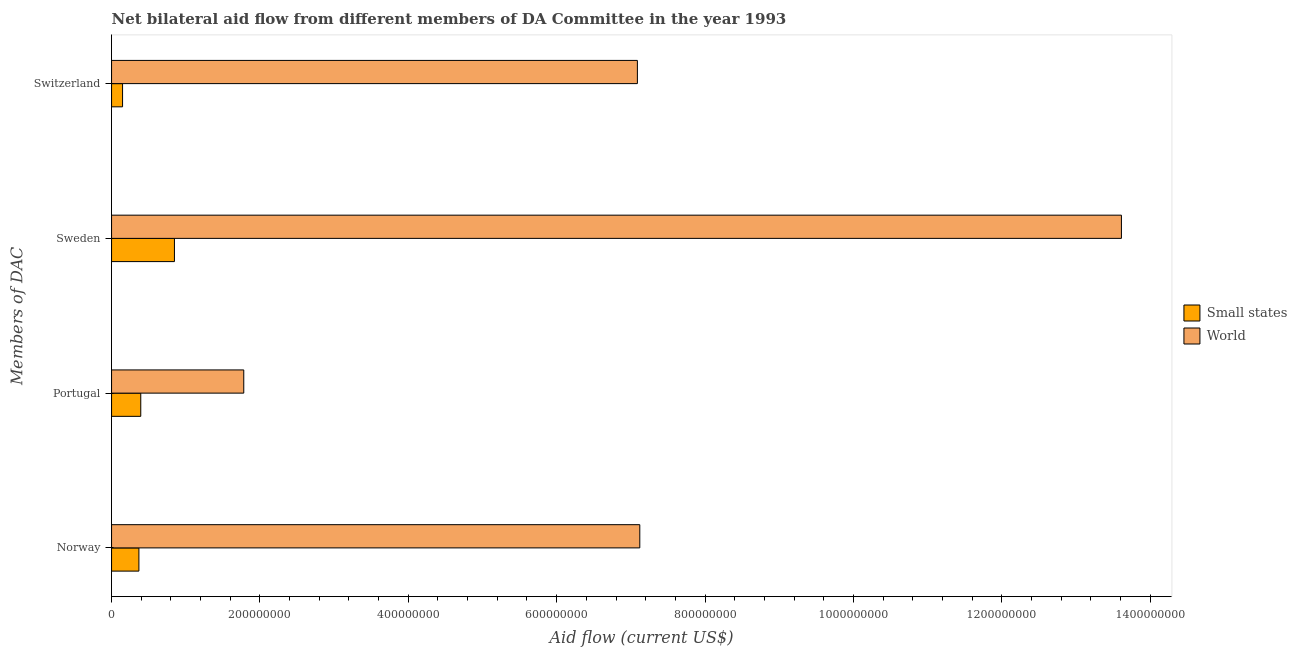How many different coloured bars are there?
Your answer should be very brief. 2. How many groups of bars are there?
Your answer should be very brief. 4. Are the number of bars per tick equal to the number of legend labels?
Your answer should be very brief. Yes. How many bars are there on the 3rd tick from the bottom?
Keep it short and to the point. 2. What is the label of the 2nd group of bars from the top?
Provide a short and direct response. Sweden. What is the amount of aid given by sweden in Small states?
Provide a succinct answer. 8.48e+07. Across all countries, what is the maximum amount of aid given by portugal?
Provide a short and direct response. 1.78e+08. Across all countries, what is the minimum amount of aid given by norway?
Your answer should be very brief. 3.69e+07. In which country was the amount of aid given by sweden minimum?
Provide a succinct answer. Small states. What is the total amount of aid given by sweden in the graph?
Your answer should be very brief. 1.45e+09. What is the difference between the amount of aid given by sweden in World and that in Small states?
Ensure brevity in your answer.  1.28e+09. What is the difference between the amount of aid given by norway in World and the amount of aid given by switzerland in Small states?
Your answer should be very brief. 6.97e+08. What is the average amount of aid given by portugal per country?
Your response must be concise. 1.09e+08. What is the difference between the amount of aid given by sweden and amount of aid given by norway in Small states?
Make the answer very short. 4.79e+07. What is the ratio of the amount of aid given by sweden in World to that in Small states?
Keep it short and to the point. 16.06. Is the difference between the amount of aid given by switzerland in Small states and World greater than the difference between the amount of aid given by norway in Small states and World?
Your response must be concise. No. What is the difference between the highest and the second highest amount of aid given by portugal?
Keep it short and to the point. 1.39e+08. What is the difference between the highest and the lowest amount of aid given by norway?
Keep it short and to the point. 6.75e+08. What does the 2nd bar from the top in Norway represents?
Keep it short and to the point. Small states. How many countries are there in the graph?
Offer a terse response. 2. Are the values on the major ticks of X-axis written in scientific E-notation?
Your answer should be compact. No. Does the graph contain any zero values?
Provide a succinct answer. No. Does the graph contain grids?
Your answer should be very brief. No. What is the title of the graph?
Provide a short and direct response. Net bilateral aid flow from different members of DA Committee in the year 1993. What is the label or title of the X-axis?
Offer a terse response. Aid flow (current US$). What is the label or title of the Y-axis?
Your answer should be very brief. Members of DAC. What is the Aid flow (current US$) of Small states in Norway?
Your response must be concise. 3.69e+07. What is the Aid flow (current US$) in World in Norway?
Offer a very short reply. 7.12e+08. What is the Aid flow (current US$) of Small states in Portugal?
Provide a short and direct response. 3.94e+07. What is the Aid flow (current US$) of World in Portugal?
Make the answer very short. 1.78e+08. What is the Aid flow (current US$) of Small states in Sweden?
Give a very brief answer. 8.48e+07. What is the Aid flow (current US$) in World in Sweden?
Give a very brief answer. 1.36e+09. What is the Aid flow (current US$) of Small states in Switzerland?
Offer a very short reply. 1.48e+07. What is the Aid flow (current US$) of World in Switzerland?
Offer a terse response. 7.09e+08. Across all Members of DAC, what is the maximum Aid flow (current US$) in Small states?
Provide a succinct answer. 8.48e+07. Across all Members of DAC, what is the maximum Aid flow (current US$) in World?
Offer a very short reply. 1.36e+09. Across all Members of DAC, what is the minimum Aid flow (current US$) in Small states?
Keep it short and to the point. 1.48e+07. Across all Members of DAC, what is the minimum Aid flow (current US$) of World?
Provide a succinct answer. 1.78e+08. What is the total Aid flow (current US$) of Small states in the graph?
Offer a very short reply. 1.76e+08. What is the total Aid flow (current US$) of World in the graph?
Ensure brevity in your answer.  2.96e+09. What is the difference between the Aid flow (current US$) in Small states in Norway and that in Portugal?
Your response must be concise. -2.51e+06. What is the difference between the Aid flow (current US$) of World in Norway and that in Portugal?
Your answer should be very brief. 5.34e+08. What is the difference between the Aid flow (current US$) in Small states in Norway and that in Sweden?
Ensure brevity in your answer.  -4.79e+07. What is the difference between the Aid flow (current US$) in World in Norway and that in Sweden?
Ensure brevity in your answer.  -6.49e+08. What is the difference between the Aid flow (current US$) in Small states in Norway and that in Switzerland?
Make the answer very short. 2.20e+07. What is the difference between the Aid flow (current US$) of World in Norway and that in Switzerland?
Keep it short and to the point. 3.25e+06. What is the difference between the Aid flow (current US$) in Small states in Portugal and that in Sweden?
Offer a terse response. -4.54e+07. What is the difference between the Aid flow (current US$) in World in Portugal and that in Sweden?
Offer a terse response. -1.18e+09. What is the difference between the Aid flow (current US$) in Small states in Portugal and that in Switzerland?
Keep it short and to the point. 2.46e+07. What is the difference between the Aid flow (current US$) of World in Portugal and that in Switzerland?
Your answer should be compact. -5.31e+08. What is the difference between the Aid flow (current US$) of Small states in Sweden and that in Switzerland?
Your answer should be very brief. 6.99e+07. What is the difference between the Aid flow (current US$) in World in Sweden and that in Switzerland?
Keep it short and to the point. 6.52e+08. What is the difference between the Aid flow (current US$) of Small states in Norway and the Aid flow (current US$) of World in Portugal?
Provide a succinct answer. -1.41e+08. What is the difference between the Aid flow (current US$) in Small states in Norway and the Aid flow (current US$) in World in Sweden?
Provide a short and direct response. -1.32e+09. What is the difference between the Aid flow (current US$) of Small states in Norway and the Aid flow (current US$) of World in Switzerland?
Ensure brevity in your answer.  -6.72e+08. What is the difference between the Aid flow (current US$) of Small states in Portugal and the Aid flow (current US$) of World in Sweden?
Provide a succinct answer. -1.32e+09. What is the difference between the Aid flow (current US$) in Small states in Portugal and the Aid flow (current US$) in World in Switzerland?
Provide a short and direct response. -6.69e+08. What is the difference between the Aid flow (current US$) in Small states in Sweden and the Aid flow (current US$) in World in Switzerland?
Provide a short and direct response. -6.24e+08. What is the average Aid flow (current US$) in Small states per Members of DAC?
Keep it short and to the point. 4.40e+07. What is the average Aid flow (current US$) of World per Members of DAC?
Provide a succinct answer. 7.40e+08. What is the difference between the Aid flow (current US$) in Small states and Aid flow (current US$) in World in Norway?
Your answer should be very brief. -6.75e+08. What is the difference between the Aid flow (current US$) in Small states and Aid flow (current US$) in World in Portugal?
Offer a very short reply. -1.39e+08. What is the difference between the Aid flow (current US$) of Small states and Aid flow (current US$) of World in Sweden?
Provide a succinct answer. -1.28e+09. What is the difference between the Aid flow (current US$) in Small states and Aid flow (current US$) in World in Switzerland?
Provide a short and direct response. -6.94e+08. What is the ratio of the Aid flow (current US$) of Small states in Norway to that in Portugal?
Your answer should be compact. 0.94. What is the ratio of the Aid flow (current US$) of World in Norway to that in Portugal?
Offer a terse response. 4. What is the ratio of the Aid flow (current US$) of Small states in Norway to that in Sweden?
Offer a very short reply. 0.43. What is the ratio of the Aid flow (current US$) of World in Norway to that in Sweden?
Ensure brevity in your answer.  0.52. What is the ratio of the Aid flow (current US$) of Small states in Norway to that in Switzerland?
Provide a short and direct response. 2.49. What is the ratio of the Aid flow (current US$) in Small states in Portugal to that in Sweden?
Your response must be concise. 0.46. What is the ratio of the Aid flow (current US$) of World in Portugal to that in Sweden?
Your answer should be compact. 0.13. What is the ratio of the Aid flow (current US$) in Small states in Portugal to that in Switzerland?
Make the answer very short. 2.66. What is the ratio of the Aid flow (current US$) of World in Portugal to that in Switzerland?
Offer a terse response. 0.25. What is the ratio of the Aid flow (current US$) of Small states in Sweden to that in Switzerland?
Your response must be concise. 5.72. What is the ratio of the Aid flow (current US$) in World in Sweden to that in Switzerland?
Ensure brevity in your answer.  1.92. What is the difference between the highest and the second highest Aid flow (current US$) in Small states?
Ensure brevity in your answer.  4.54e+07. What is the difference between the highest and the second highest Aid flow (current US$) in World?
Keep it short and to the point. 6.49e+08. What is the difference between the highest and the lowest Aid flow (current US$) in Small states?
Your response must be concise. 6.99e+07. What is the difference between the highest and the lowest Aid flow (current US$) of World?
Your answer should be compact. 1.18e+09. 